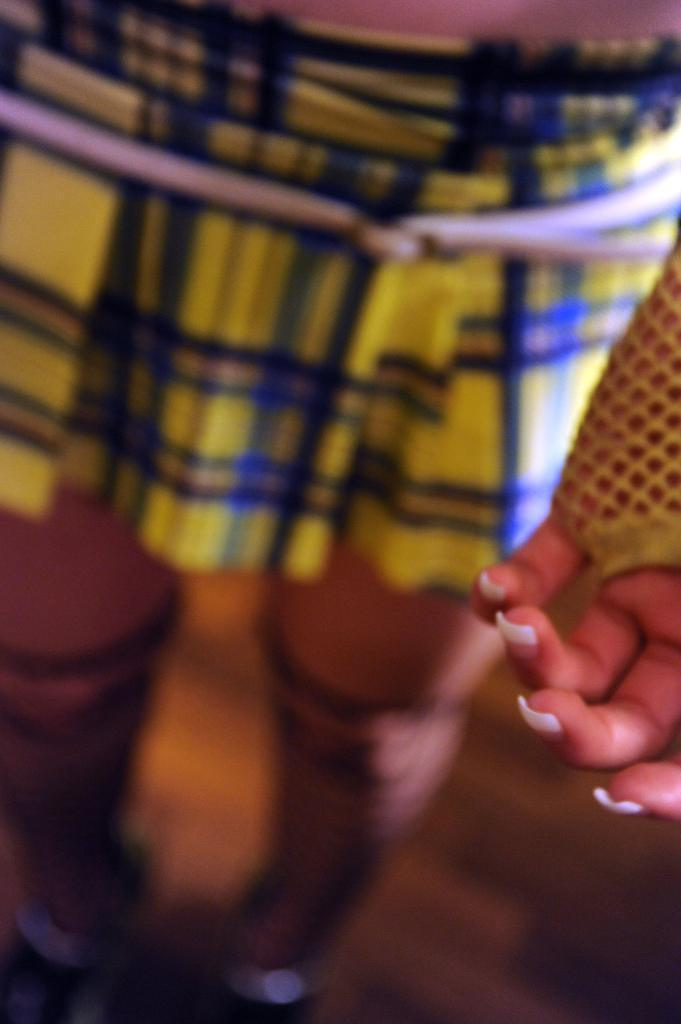What body parts can be seen in the image? There are legs and a hand visible in the image. What type of street is visible in the image? There is no street visible in the image; only legs and a hand can be seen. How many clocks are present in the image? There is no mention of clocks in the image; only legs and a hand are visible. 